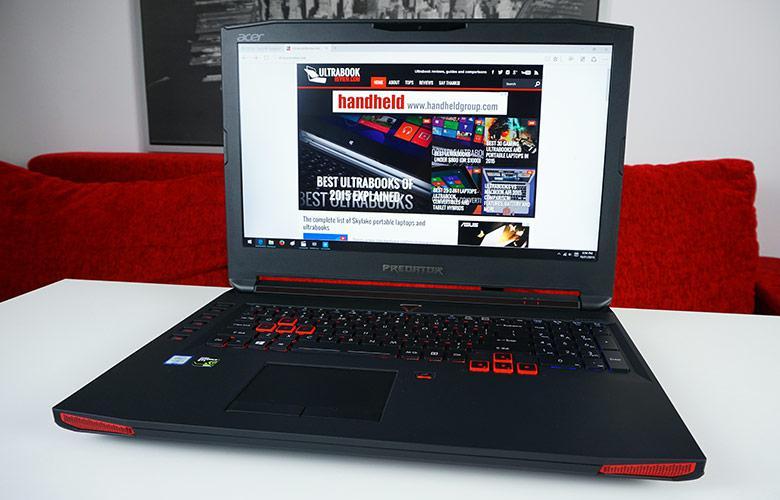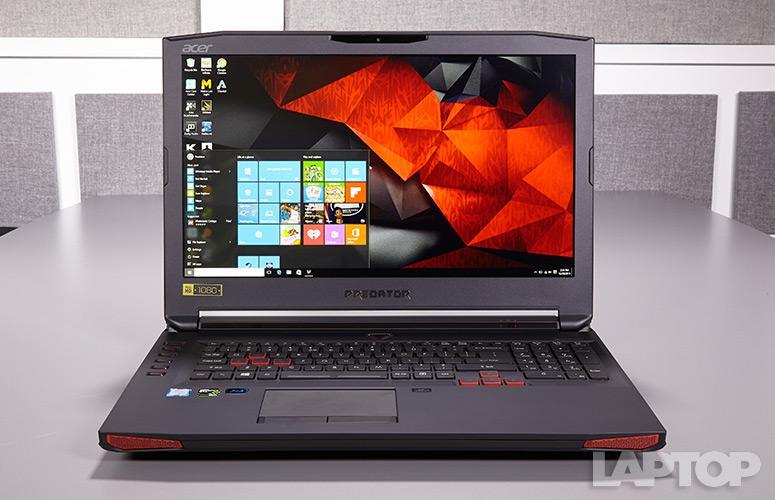The first image is the image on the left, the second image is the image on the right. Analyze the images presented: Is the assertion "The laptop on the left is opened to at least 90-degrees and has its screen facing somewhat forward, and the laptop on the right is open to about 45-degrees or less and has its back to the camera." valid? Answer yes or no. No. The first image is the image on the left, the second image is the image on the right. For the images shown, is this caption "The computer in the image on the right is angled so that the screen isn't visible." true? Answer yes or no. No. 